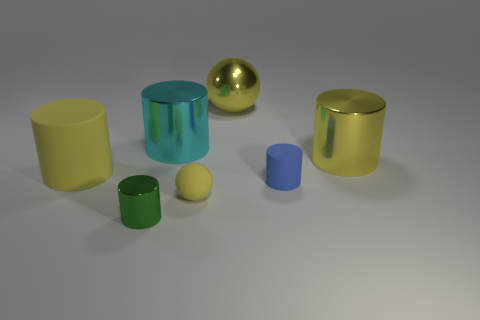Subtract all green cylinders. How many cylinders are left? 4 Subtract all yellow metallic cylinders. How many cylinders are left? 4 Subtract all gray cylinders. Subtract all blue spheres. How many cylinders are left? 5 Add 1 yellow rubber balls. How many objects exist? 8 Subtract all cylinders. How many objects are left? 2 Subtract 1 yellow spheres. How many objects are left? 6 Subtract all big cyan metallic cylinders. Subtract all rubber spheres. How many objects are left? 5 Add 7 large cyan metal cylinders. How many large cyan metal cylinders are left? 8 Add 2 green shiny cylinders. How many green shiny cylinders exist? 3 